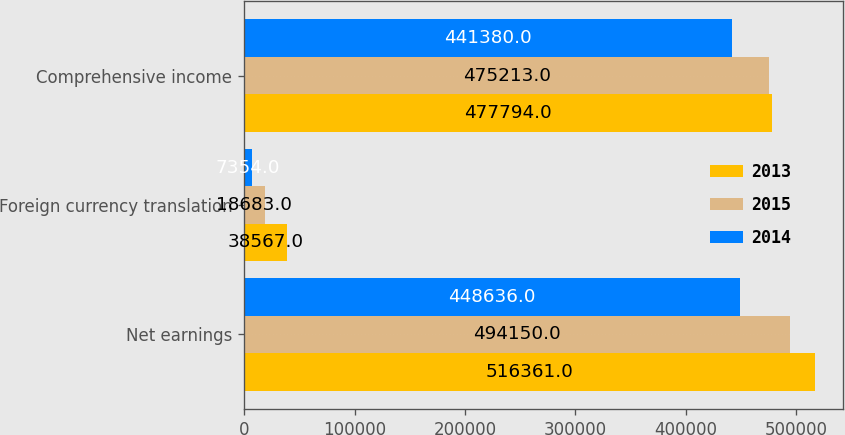Convert chart to OTSL. <chart><loc_0><loc_0><loc_500><loc_500><stacked_bar_chart><ecel><fcel>Net earnings<fcel>Foreign currency translation<fcel>Comprehensive income<nl><fcel>2013<fcel>516361<fcel>38567<fcel>477794<nl><fcel>2015<fcel>494150<fcel>18683<fcel>475213<nl><fcel>2014<fcel>448636<fcel>7354<fcel>441380<nl></chart> 